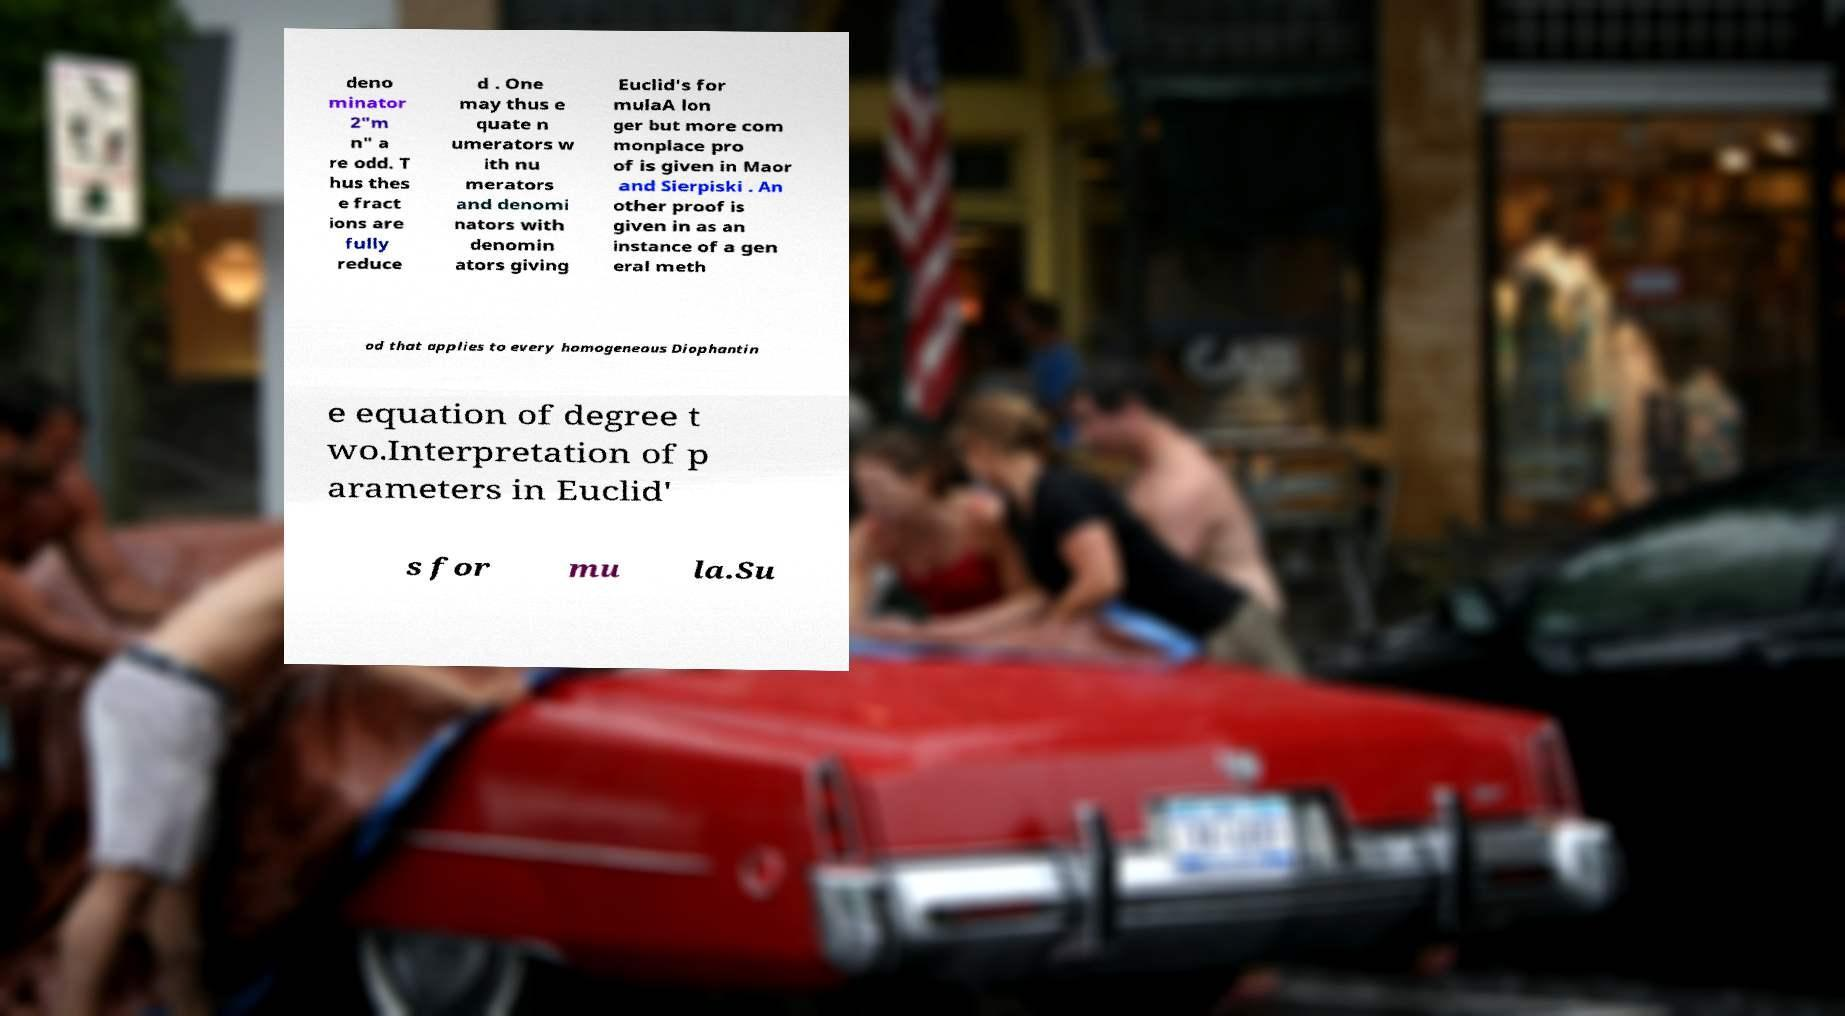There's text embedded in this image that I need extracted. Can you transcribe it verbatim? deno minator 2"m n" a re odd. T hus thes e fract ions are fully reduce d . One may thus e quate n umerators w ith nu merators and denomi nators with denomin ators giving Euclid's for mulaA lon ger but more com monplace pro of is given in Maor and Sierpiski . An other proof is given in as an instance of a gen eral meth od that applies to every homogeneous Diophantin e equation of degree t wo.Interpretation of p arameters in Euclid' s for mu la.Su 